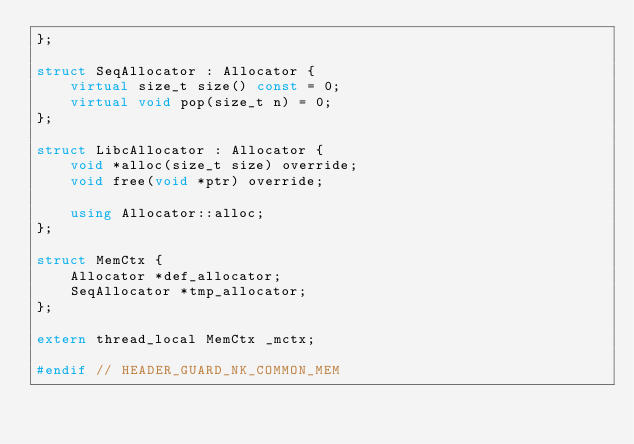Convert code to text. <code><loc_0><loc_0><loc_500><loc_500><_C++_>};

struct SeqAllocator : Allocator {
    virtual size_t size() const = 0;
    virtual void pop(size_t n) = 0;
};

struct LibcAllocator : Allocator {
    void *alloc(size_t size) override;
    void free(void *ptr) override;

    using Allocator::alloc;
};

struct MemCtx {
    Allocator *def_allocator;
    SeqAllocator *tmp_allocator;
};

extern thread_local MemCtx _mctx;

#endif // HEADER_GUARD_NK_COMMON_MEM
</code> 